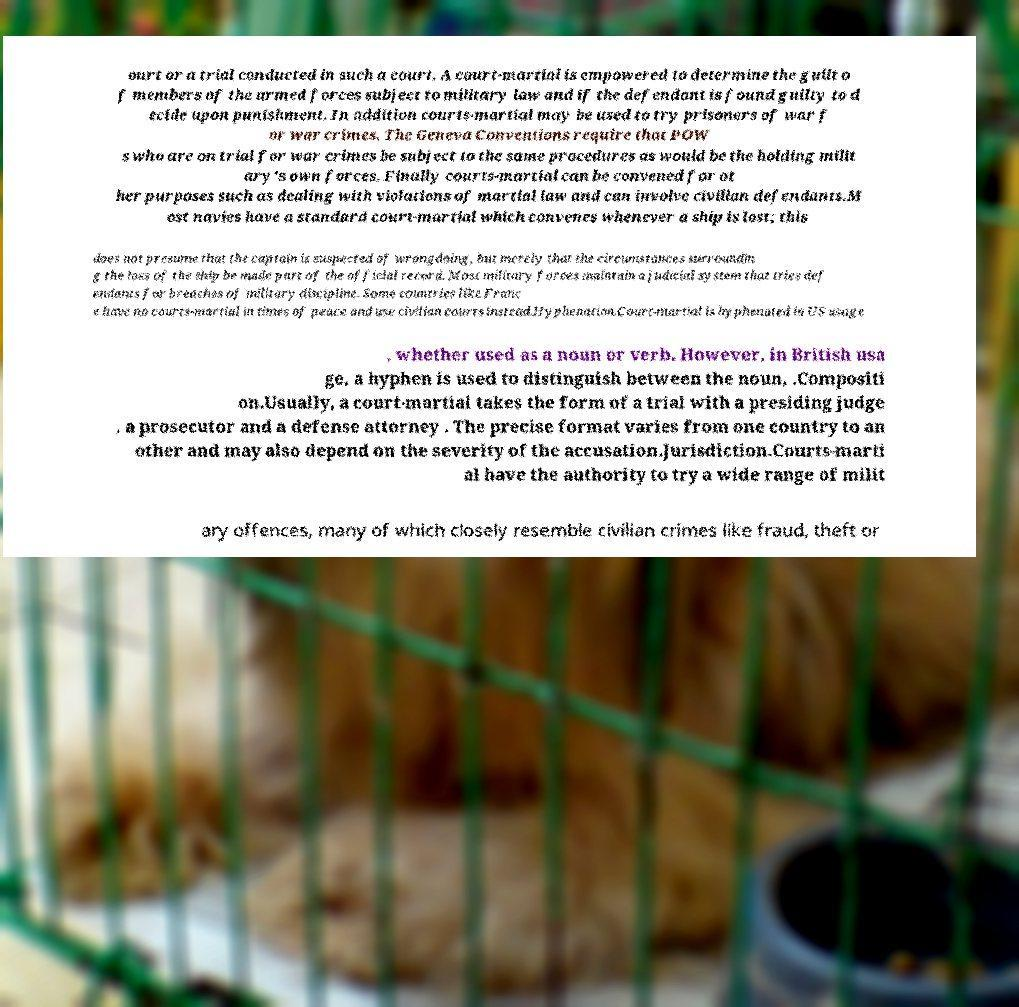Please read and relay the text visible in this image. What does it say? ourt or a trial conducted in such a court. A court-martial is empowered to determine the guilt o f members of the armed forces subject to military law and if the defendant is found guilty to d ecide upon punishment. In addition courts-martial may be used to try prisoners of war f or war crimes. The Geneva Conventions require that POW s who are on trial for war crimes be subject to the same procedures as would be the holding milit ary's own forces. Finally courts-martial can be convened for ot her purposes such as dealing with violations of martial law and can involve civilian defendants.M ost navies have a standard court-martial which convenes whenever a ship is lost; this does not presume that the captain is suspected of wrongdoing, but merely that the circumstances surroundin g the loss of the ship be made part of the official record. Most military forces maintain a judicial system that tries def endants for breaches of military discipline. Some countries like Franc e have no courts-martial in times of peace and use civilian courts instead.Hyphenation.Court-martial is hyphenated in US usage , whether used as a noun or verb. However, in British usa ge, a hyphen is used to distinguish between the noun, .Compositi on.Usually, a court-martial takes the form of a trial with a presiding judge , a prosecutor and a defense attorney . The precise format varies from one country to an other and may also depend on the severity of the accusation.Jurisdiction.Courts-marti al have the authority to try a wide range of milit ary offences, many of which closely resemble civilian crimes like fraud, theft or 